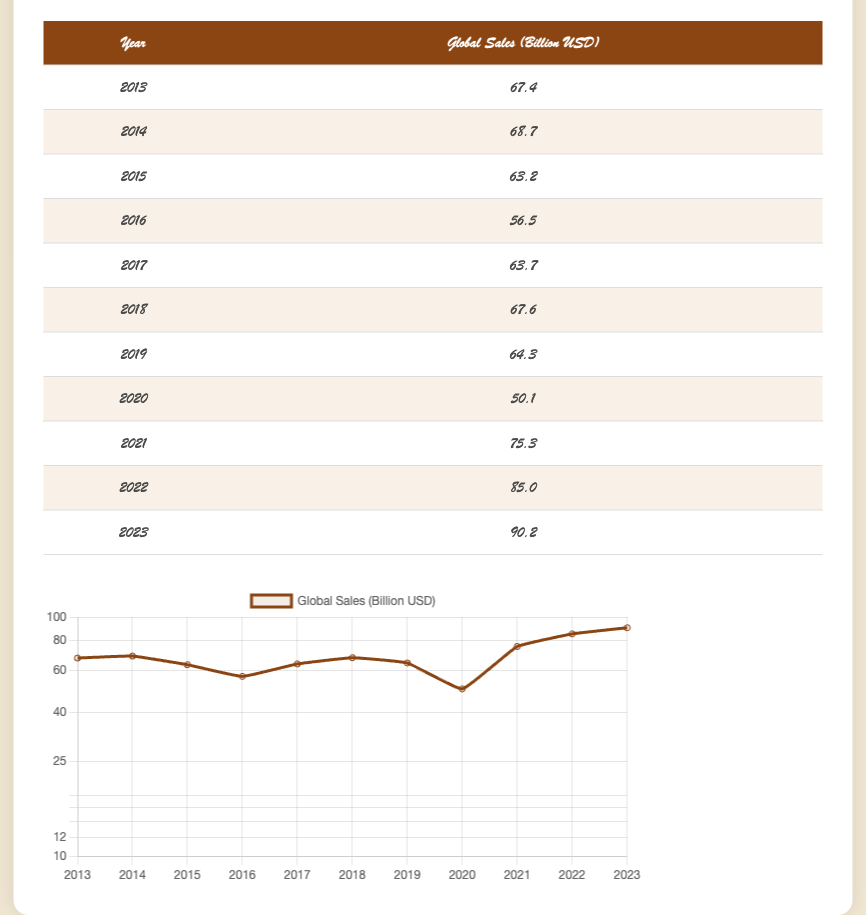What was the highest global sales revenue recorded in the table? The table shows the global sales revenue for each year. The highest value can be identified by scanning through the last column to find the maximum number. The global sales peaked in 2023 at 90.2 billion USD.
Answer: 90.2 What year experienced the lowest global sales revenue? Looking at the table, the global sales revenue from each year is listed, and by identifying the minimum value, we find that 2020 had the lowest sales at 50.1 billion USD.
Answer: 2020 What is the total global sales revenue from 2018 to 2023? The global sales figures between 2018 and 2023 need to be summed up. The values are 67.6 (2018) + 64.3 (2019) + 50.1 (2020) + 75.3 (2021) + 85.0 (2022) + 90.2 (2023). Adding these together: 67.6 + 64.3 + 50.1 + 75.3 + 85.0 + 90.2 equals 432.5 billion USD.
Answer: 432.5 Did global sales revenue ever decline from one year to the next in the table? A quick review of the annual sales figures shows whether there was a decrease from one year to the next. Comparing the years, we see that 2015 to 2016 and 2019 to 2020 had declines in sales. Thus, the answer is yes.
Answer: Yes What was the average global sales revenue for the years 2013 to 2017? The average can be found by first summing the sales for the years 2013 (67.4), 2014 (68.7), 2015 (63.2), 2016 (56.5), and 2017 (63.7). The total equals 67.4 + 68.7 + 63.2 + 56.5 + 63.7 = 319.5 billion USD. There are 5 years, so dividing 319.5 by 5 gives an average of 63.9 billion USD.
Answer: 63.9 What is the percentage increase in global sales from 2020 to 2021? First, calculate the increase by subtracting the sales in 2020 (50.1) from sales in 2021 (75.3). The increase is 75.3 - 50.1 = 25.2 billion USD. To find the percentage increase, divide the increase by the 2020 sales and multiply by 100. The calculation is (25.2 / 50.1) * 100 which is approximately 50.2%.
Answer: 50.2 